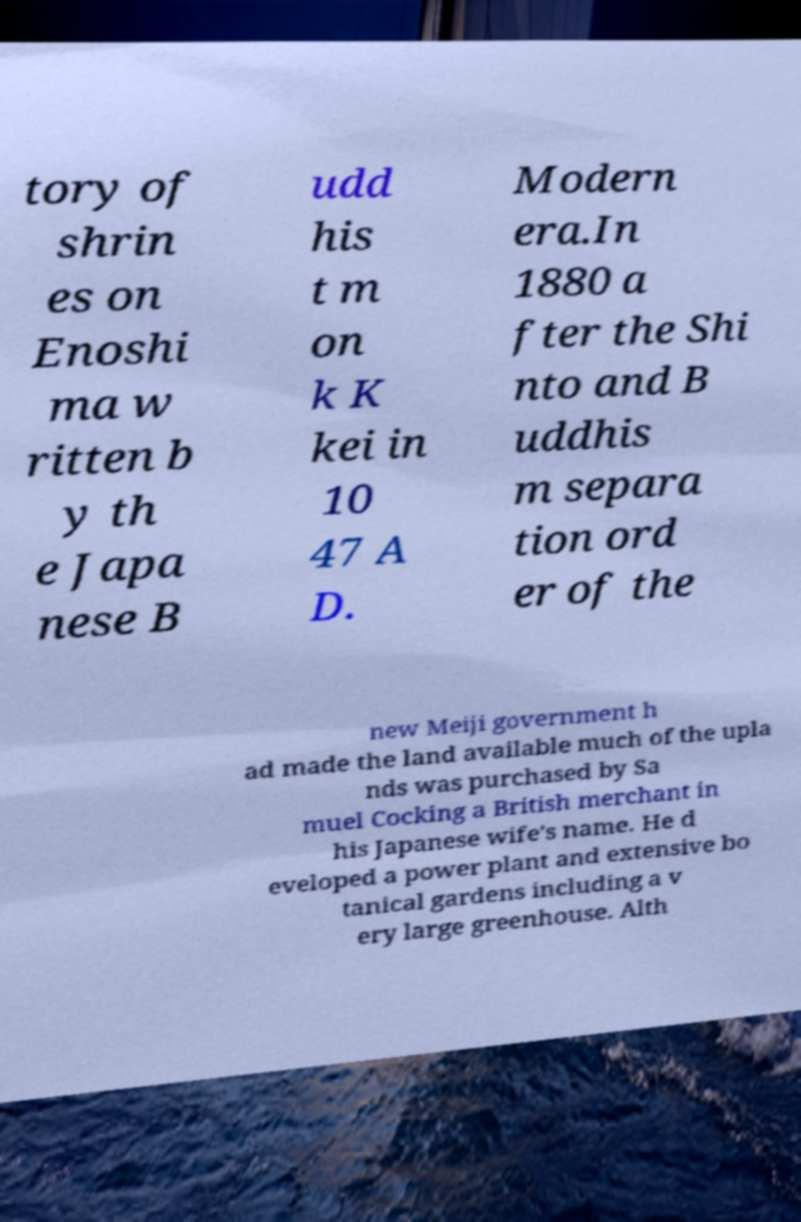Could you assist in decoding the text presented in this image and type it out clearly? tory of shrin es on Enoshi ma w ritten b y th e Japa nese B udd his t m on k K kei in 10 47 A D. Modern era.In 1880 a fter the Shi nto and B uddhis m separa tion ord er of the new Meiji government h ad made the land available much of the upla nds was purchased by Sa muel Cocking a British merchant in his Japanese wife's name. He d eveloped a power plant and extensive bo tanical gardens including a v ery large greenhouse. Alth 